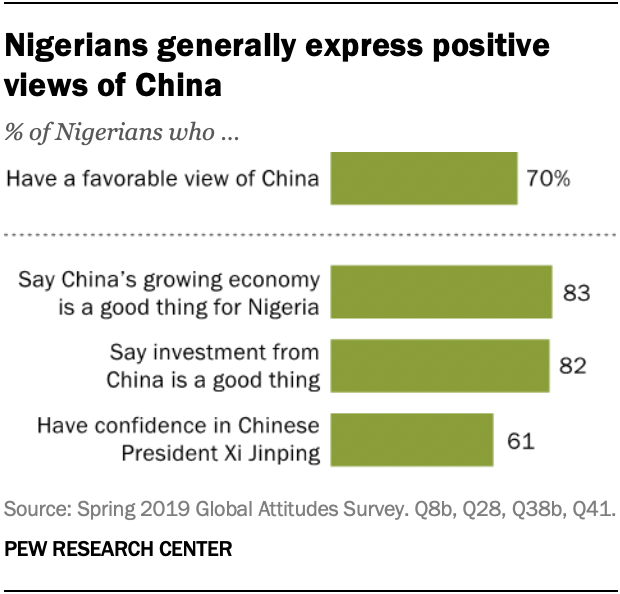Draw attention to some important aspects in this diagram. The top graph represents 70% of the total value. 